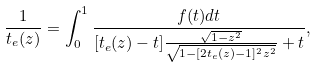Convert formula to latex. <formula><loc_0><loc_0><loc_500><loc_500>\frac { 1 } { t _ { e } ( z ) } = \int _ { 0 } ^ { 1 } \frac { f ( t ) d t } { [ t _ { e } ( z ) - t ] \frac { \sqrt { 1 - z ^ { 2 } } } { \sqrt { 1 - [ 2 t _ { e } ( z ) - 1 ] ^ { 2 } z ^ { 2 } } } + t } ,</formula> 